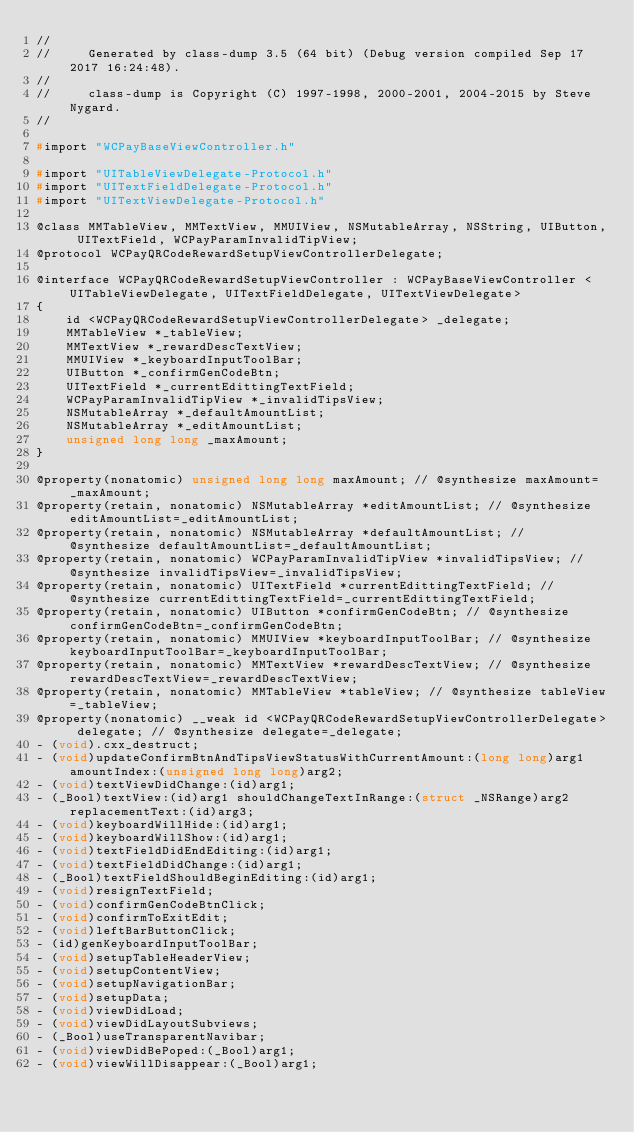Convert code to text. <code><loc_0><loc_0><loc_500><loc_500><_C_>//
//     Generated by class-dump 3.5 (64 bit) (Debug version compiled Sep 17 2017 16:24:48).
//
//     class-dump is Copyright (C) 1997-1998, 2000-2001, 2004-2015 by Steve Nygard.
//

#import "WCPayBaseViewController.h"

#import "UITableViewDelegate-Protocol.h"
#import "UITextFieldDelegate-Protocol.h"
#import "UITextViewDelegate-Protocol.h"

@class MMTableView, MMTextView, MMUIView, NSMutableArray, NSString, UIButton, UITextField, WCPayParamInvalidTipView;
@protocol WCPayQRCodeRewardSetupViewControllerDelegate;

@interface WCPayQRCodeRewardSetupViewController : WCPayBaseViewController <UITableViewDelegate, UITextFieldDelegate, UITextViewDelegate>
{
    id <WCPayQRCodeRewardSetupViewControllerDelegate> _delegate;
    MMTableView *_tableView;
    MMTextView *_rewardDescTextView;
    MMUIView *_keyboardInputToolBar;
    UIButton *_confirmGenCodeBtn;
    UITextField *_currentEdittingTextField;
    WCPayParamInvalidTipView *_invalidTipsView;
    NSMutableArray *_defaultAmountList;
    NSMutableArray *_editAmountList;
    unsigned long long _maxAmount;
}

@property(nonatomic) unsigned long long maxAmount; // @synthesize maxAmount=_maxAmount;
@property(retain, nonatomic) NSMutableArray *editAmountList; // @synthesize editAmountList=_editAmountList;
@property(retain, nonatomic) NSMutableArray *defaultAmountList; // @synthesize defaultAmountList=_defaultAmountList;
@property(retain, nonatomic) WCPayParamInvalidTipView *invalidTipsView; // @synthesize invalidTipsView=_invalidTipsView;
@property(retain, nonatomic) UITextField *currentEdittingTextField; // @synthesize currentEdittingTextField=_currentEdittingTextField;
@property(retain, nonatomic) UIButton *confirmGenCodeBtn; // @synthesize confirmGenCodeBtn=_confirmGenCodeBtn;
@property(retain, nonatomic) MMUIView *keyboardInputToolBar; // @synthesize keyboardInputToolBar=_keyboardInputToolBar;
@property(retain, nonatomic) MMTextView *rewardDescTextView; // @synthesize rewardDescTextView=_rewardDescTextView;
@property(retain, nonatomic) MMTableView *tableView; // @synthesize tableView=_tableView;
@property(nonatomic) __weak id <WCPayQRCodeRewardSetupViewControllerDelegate> delegate; // @synthesize delegate=_delegate;
- (void).cxx_destruct;
- (void)updateConfirmBtnAndTipsViewStatusWithCurrentAmount:(long long)arg1 amountIndex:(unsigned long long)arg2;
- (void)textViewDidChange:(id)arg1;
- (_Bool)textView:(id)arg1 shouldChangeTextInRange:(struct _NSRange)arg2 replacementText:(id)arg3;
- (void)keyboardWillHide:(id)arg1;
- (void)keyboardWillShow:(id)arg1;
- (void)textFieldDidEndEditing:(id)arg1;
- (void)textFieldDidChange:(id)arg1;
- (_Bool)textFieldShouldBeginEditing:(id)arg1;
- (void)resignTextField;
- (void)confirmGenCodeBtnClick;
- (void)confirmToExitEdit;
- (void)leftBarButtonClick;
- (id)genKeyboardInputToolBar;
- (void)setupTableHeaderView;
- (void)setupContentView;
- (void)setupNavigationBar;
- (void)setupData;
- (void)viewDidLoad;
- (void)viewDidLayoutSubviews;
- (_Bool)useTransparentNavibar;
- (void)viewDidBePoped:(_Bool)arg1;
- (void)viewWillDisappear:(_Bool)arg1;</code> 